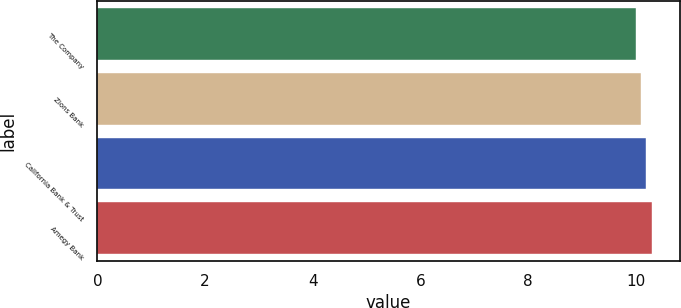Convert chart. <chart><loc_0><loc_0><loc_500><loc_500><bar_chart><fcel>The Company<fcel>Zions Bank<fcel>California Bank & Trust<fcel>Amegy Bank<nl><fcel>10<fcel>10.1<fcel>10.2<fcel>10.3<nl></chart> 